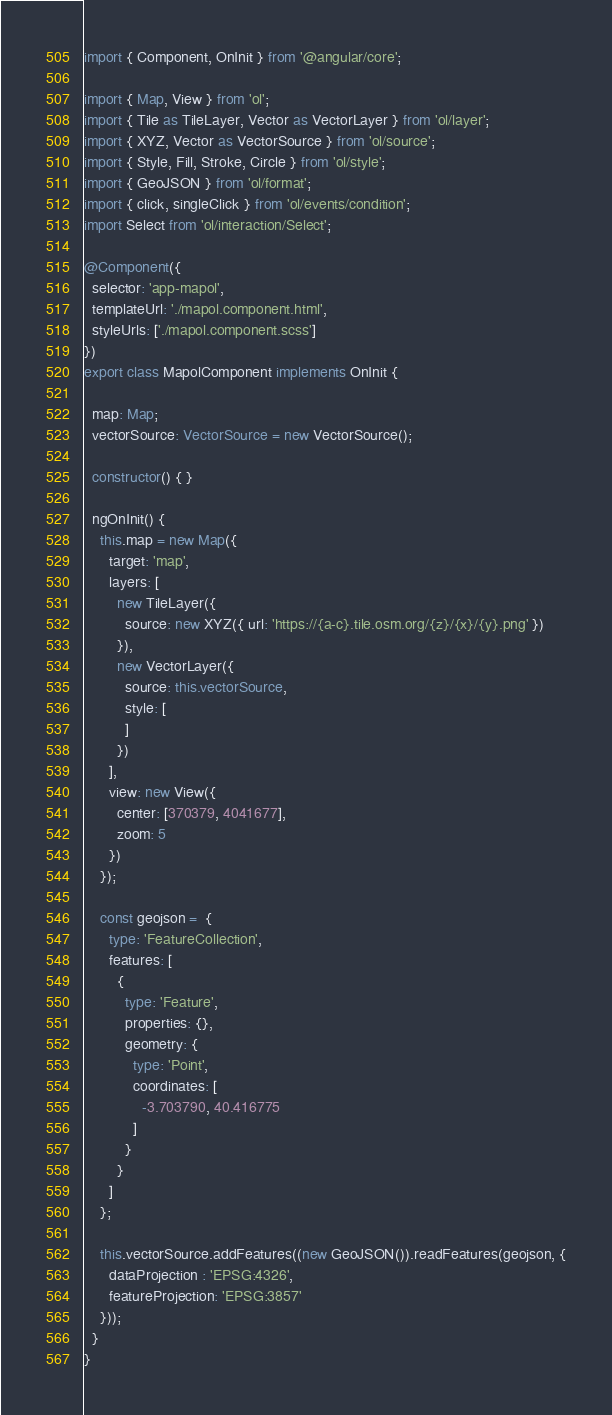<code> <loc_0><loc_0><loc_500><loc_500><_TypeScript_>import { Component, OnInit } from '@angular/core';

import { Map, View } from 'ol';
import { Tile as TileLayer, Vector as VectorLayer } from 'ol/layer';
import { XYZ, Vector as VectorSource } from 'ol/source';
import { Style, Fill, Stroke, Circle } from 'ol/style';
import { GeoJSON } from 'ol/format';
import { click, singleClick } from 'ol/events/condition';
import Select from 'ol/interaction/Select';

@Component({
  selector: 'app-mapol',
  templateUrl: './mapol.component.html',
  styleUrls: ['./mapol.component.scss']
})
export class MapolComponent implements OnInit {

  map: Map;
  vectorSource: VectorSource = new VectorSource();

  constructor() { }

  ngOnInit() {
    this.map = new Map({
      target: 'map',
      layers: [
        new TileLayer({
          source: new XYZ({ url: 'https://{a-c}.tile.osm.org/{z}/{x}/{y}.png' })
        }),
        new VectorLayer({
          source: this.vectorSource,
          style: [
          ]
        })
      ],
      view: new View({
        center: [370379, 4041677],
        zoom: 5
      })
    });

    const geojson =  {
      type: 'FeatureCollection',
      features: [
        {
          type: 'Feature',
          properties: {},
          geometry: {
            type: 'Point',
            coordinates: [
              -3.703790, 40.416775
            ]
          }
        }
      ]
    };

    this.vectorSource.addFeatures((new GeoJSON()).readFeatures(geojson, {
      dataProjection : 'EPSG:4326',
      featureProjection: 'EPSG:3857'
    }));
  }
}
</code> 